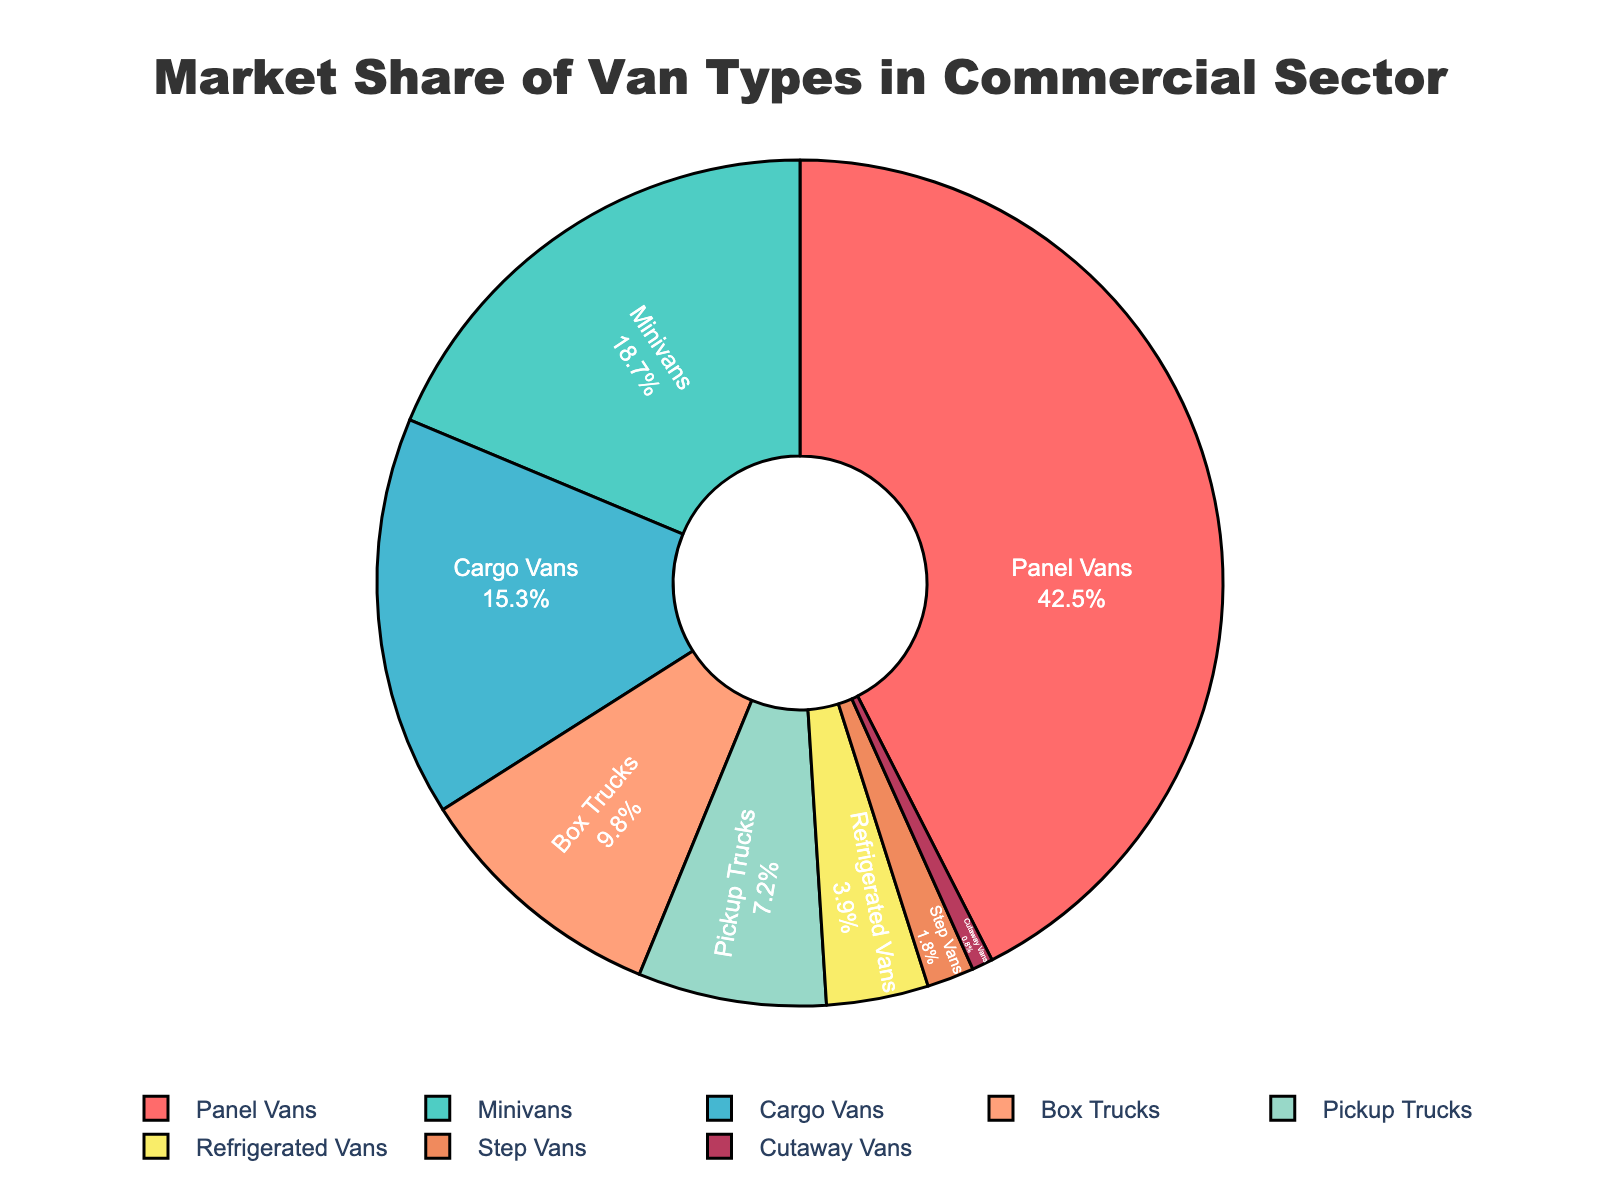Which van type has the highest market share? The van type with the largest section of the pie chart represents the highest market share.
Answer: Panel Vans What is the combined market share of Panel Vans and Minivans? Add the market share values of Panel Vans (42.5) and Minivans (18.7). The combined market share is 42.5 + 18.7.
Answer: 61.2 How much higher is the market share of Panel Vans compared to Box Trucks? Subtract the market share of Box Trucks (9.8) from the market share of Panel Vans (42.5). The difference is 42.5 - 9.8.
Answer: 32.7 Which van types have a market share less than 5%? Look for sections of the pie chart representing less than 5% market share. These van types are Refrigerated Vans (3.9), Step Vans (1.8), and Cutaway Vans (0.8).
Answer: Refrigerated Vans, Step Vans, Cutaway Vans What percentage of the market share is occupied by Pickup Trucks? Refer to the pie chart to find the section labeled with the market share. It shows Pickup Trucks at 7.2%.
Answer: 7.2% How does the market share of Cargo Vans compare to Minivans? Compare the values for Cargo Vans (15.3) and Minivans (18.7). Minivans have a higher market share than Cargo Vans.
Answer: Minivans have a higher market share If you combine the market shares of the smallest three segments, what is their total percentage? Add the market share values for the smallest three segments: Cutaway Vans (0.8), Step Vans (1.8), and Refrigerated Vans (3.9). The total is 0.8 + 1.8 + 3.9.
Answer: 6.5 Which color represents the Box Trucks in the pie chart? In the visual, identify the segment labeled Box Trucks and note its color.
Answer: Light-orange What is the difference in market share between Minivans and Pickup Trucks? Subtract the market share of Pickup Trucks (7.2) from the market share of Minivans (18.7). The difference is 18.7 - 7.2.
Answer: 11.5 What is the average market share of Cargo Vans, Pickup Trucks, and Box Trucks? Add their market shares: Cargo Vans (15.3), Pickup Trucks (7.2), and Box Trucks (9.8), then divide by 3. (15.3 + 7.2 + 9.8) / 3.
Answer: 10.77 